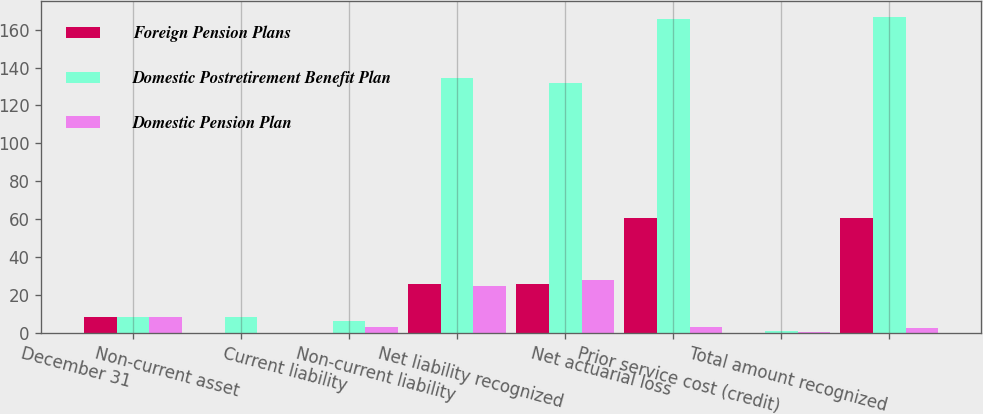<chart> <loc_0><loc_0><loc_500><loc_500><stacked_bar_chart><ecel><fcel>December 31<fcel>Non-current asset<fcel>Current liability<fcel>Non-current liability<fcel>Net liability recognized<fcel>Net actuarial loss<fcel>Prior service cost (credit)<fcel>Total amount recognized<nl><fcel>Foreign Pension Plans<fcel>8.6<fcel>0<fcel>0<fcel>25.6<fcel>25.6<fcel>60.4<fcel>0<fcel>60.4<nl><fcel>Domestic Postretirement Benefit Plan<fcel>8.6<fcel>8.6<fcel>6.2<fcel>134.5<fcel>132.1<fcel>165.6<fcel>1.2<fcel>166.8<nl><fcel>Domestic Pension Plan<fcel>8.6<fcel>0<fcel>2.9<fcel>24.8<fcel>27.7<fcel>3.1<fcel>0.3<fcel>2.8<nl></chart> 